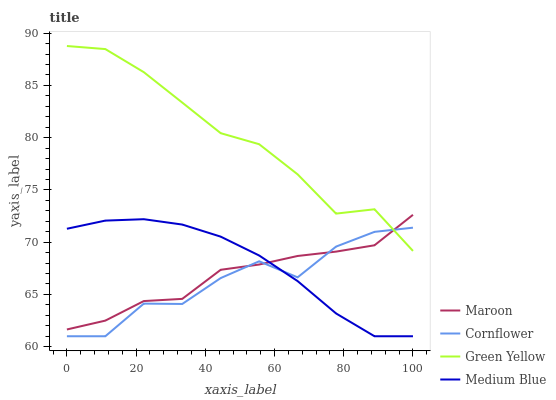Does Cornflower have the minimum area under the curve?
Answer yes or no. Yes. Does Green Yellow have the maximum area under the curve?
Answer yes or no. Yes. Does Medium Blue have the minimum area under the curve?
Answer yes or no. No. Does Medium Blue have the maximum area under the curve?
Answer yes or no. No. Is Medium Blue the smoothest?
Answer yes or no. Yes. Is Cornflower the roughest?
Answer yes or no. Yes. Is Green Yellow the smoothest?
Answer yes or no. No. Is Green Yellow the roughest?
Answer yes or no. No. Does Green Yellow have the lowest value?
Answer yes or no. No. Does Medium Blue have the highest value?
Answer yes or no. No. Is Medium Blue less than Green Yellow?
Answer yes or no. Yes. Is Green Yellow greater than Medium Blue?
Answer yes or no. Yes. Does Medium Blue intersect Green Yellow?
Answer yes or no. No. 